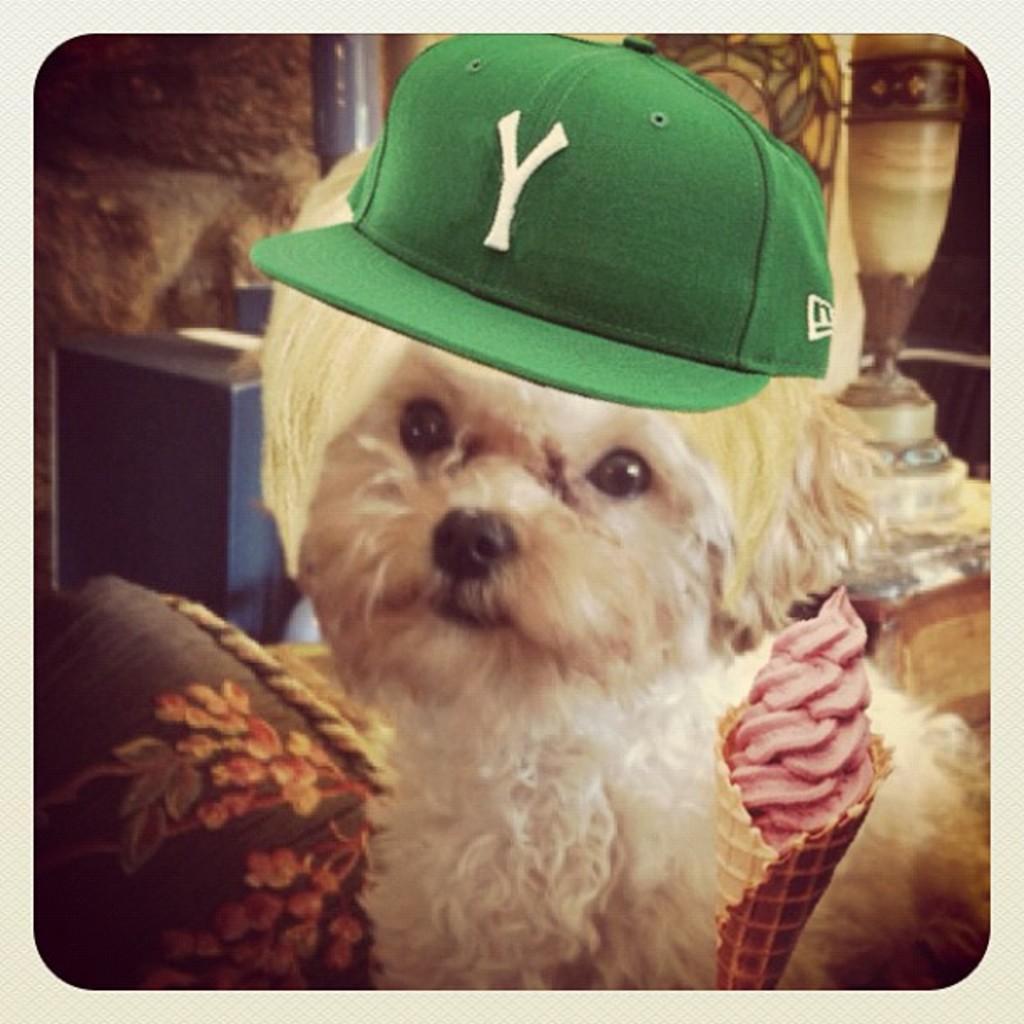How would you summarize this image in a sentence or two? In this image, we can see a dog with a cap and there is an ice cream. 